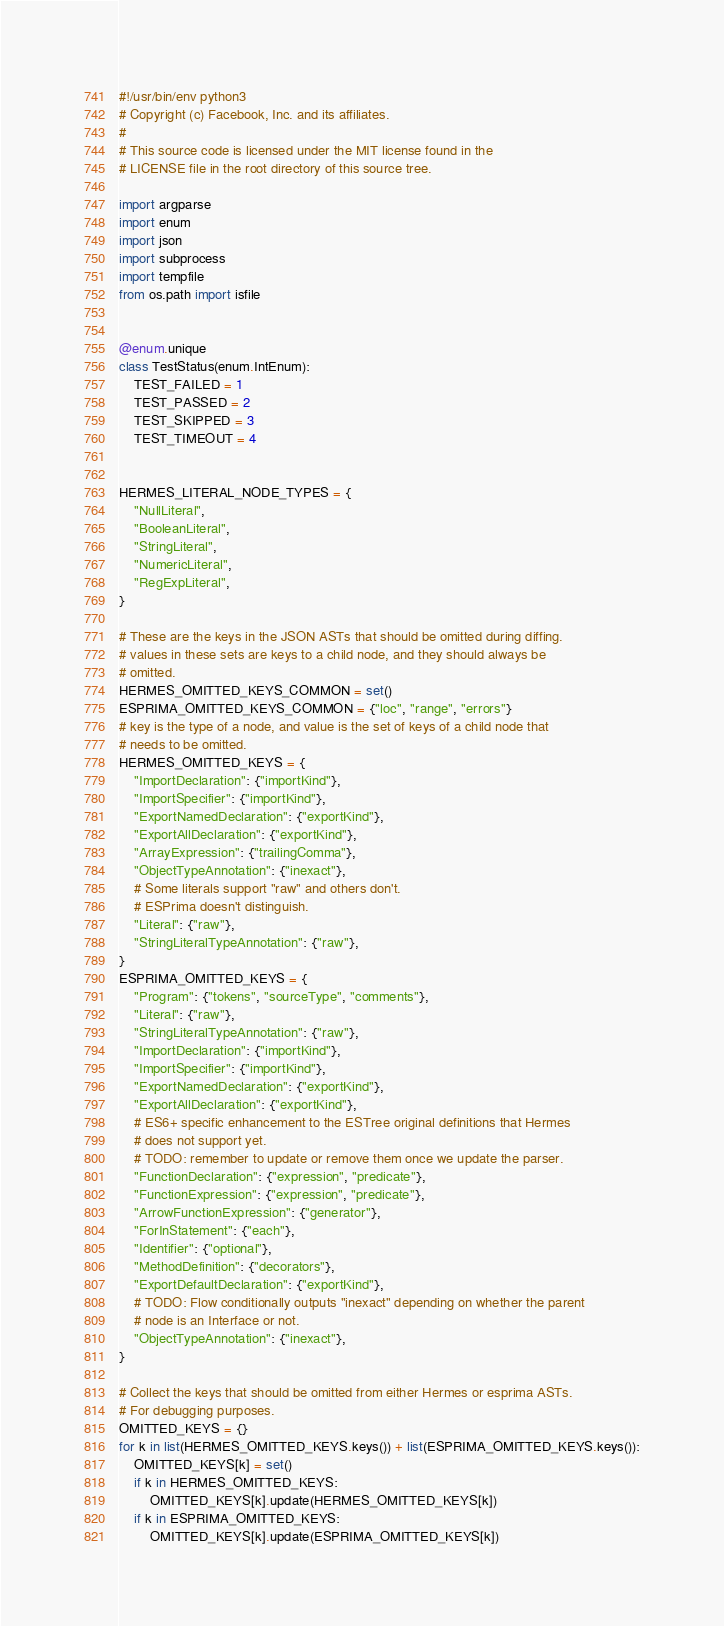Convert code to text. <code><loc_0><loc_0><loc_500><loc_500><_Python_>#!/usr/bin/env python3
# Copyright (c) Facebook, Inc. and its affiliates.
#
# This source code is licensed under the MIT license found in the
# LICENSE file in the root directory of this source tree.

import argparse
import enum
import json
import subprocess
import tempfile
from os.path import isfile


@enum.unique
class TestStatus(enum.IntEnum):
    TEST_FAILED = 1
    TEST_PASSED = 2
    TEST_SKIPPED = 3
    TEST_TIMEOUT = 4


HERMES_LITERAL_NODE_TYPES = {
    "NullLiteral",
    "BooleanLiteral",
    "StringLiteral",
    "NumericLiteral",
    "RegExpLiteral",
}

# These are the keys in the JSON ASTs that should be omitted during diffing.
# values in these sets are keys to a child node, and they should always be
# omitted.
HERMES_OMITTED_KEYS_COMMON = set()
ESPRIMA_OMITTED_KEYS_COMMON = {"loc", "range", "errors"}
# key is the type of a node, and value is the set of keys of a child node that
# needs to be omitted.
HERMES_OMITTED_KEYS = {
    "ImportDeclaration": {"importKind"},
    "ImportSpecifier": {"importKind"},
    "ExportNamedDeclaration": {"exportKind"},
    "ExportAllDeclaration": {"exportKind"},
    "ArrayExpression": {"trailingComma"},
    "ObjectTypeAnnotation": {"inexact"},
    # Some literals support "raw" and others don't.
    # ESPrima doesn't distinguish.
    "Literal": {"raw"},
    "StringLiteralTypeAnnotation": {"raw"},
}
ESPRIMA_OMITTED_KEYS = {
    "Program": {"tokens", "sourceType", "comments"},
    "Literal": {"raw"},
    "StringLiteralTypeAnnotation": {"raw"},
    "ImportDeclaration": {"importKind"},
    "ImportSpecifier": {"importKind"},
    "ExportNamedDeclaration": {"exportKind"},
    "ExportAllDeclaration": {"exportKind"},
    # ES6+ specific enhancement to the ESTree original definitions that Hermes
    # does not support yet.
    # TODO: remember to update or remove them once we update the parser.
    "FunctionDeclaration": {"expression", "predicate"},
    "FunctionExpression": {"expression", "predicate"},
    "ArrowFunctionExpression": {"generator"},
    "ForInStatement": {"each"},
    "Identifier": {"optional"},
    "MethodDefinition": {"decorators"},
    "ExportDefaultDeclaration": {"exportKind"},
    # TODO: Flow conditionally outputs "inexact" depending on whether the parent
    # node is an Interface or not.
    "ObjectTypeAnnotation": {"inexact"},
}

# Collect the keys that should be omitted from either Hermes or esprima ASTs.
# For debugging purposes.
OMITTED_KEYS = {}
for k in list(HERMES_OMITTED_KEYS.keys()) + list(ESPRIMA_OMITTED_KEYS.keys()):
    OMITTED_KEYS[k] = set()
    if k in HERMES_OMITTED_KEYS:
        OMITTED_KEYS[k].update(HERMES_OMITTED_KEYS[k])
    if k in ESPRIMA_OMITTED_KEYS:
        OMITTED_KEYS[k].update(ESPRIMA_OMITTED_KEYS[k])
</code> 